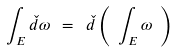<formula> <loc_0><loc_0><loc_500><loc_500>\int _ { E } \check { d } \omega \ = \ \check { d } \left ( \ \int _ { E } \omega \ \right )</formula> 